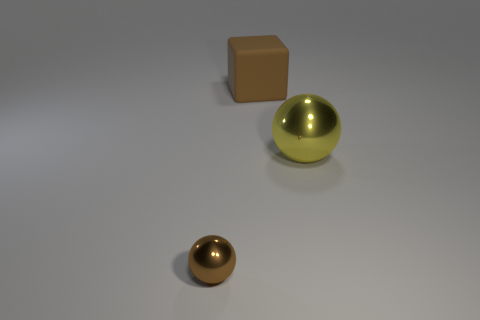Is there any indication of the size or scale of these objects? There's no direct reference for scale within the image. However, based on common experience, the objects could be interpreted as relatively small, potentially fitting comfortably on a table. Without a familiar object to compare them to, their exact size is indeterminate. 